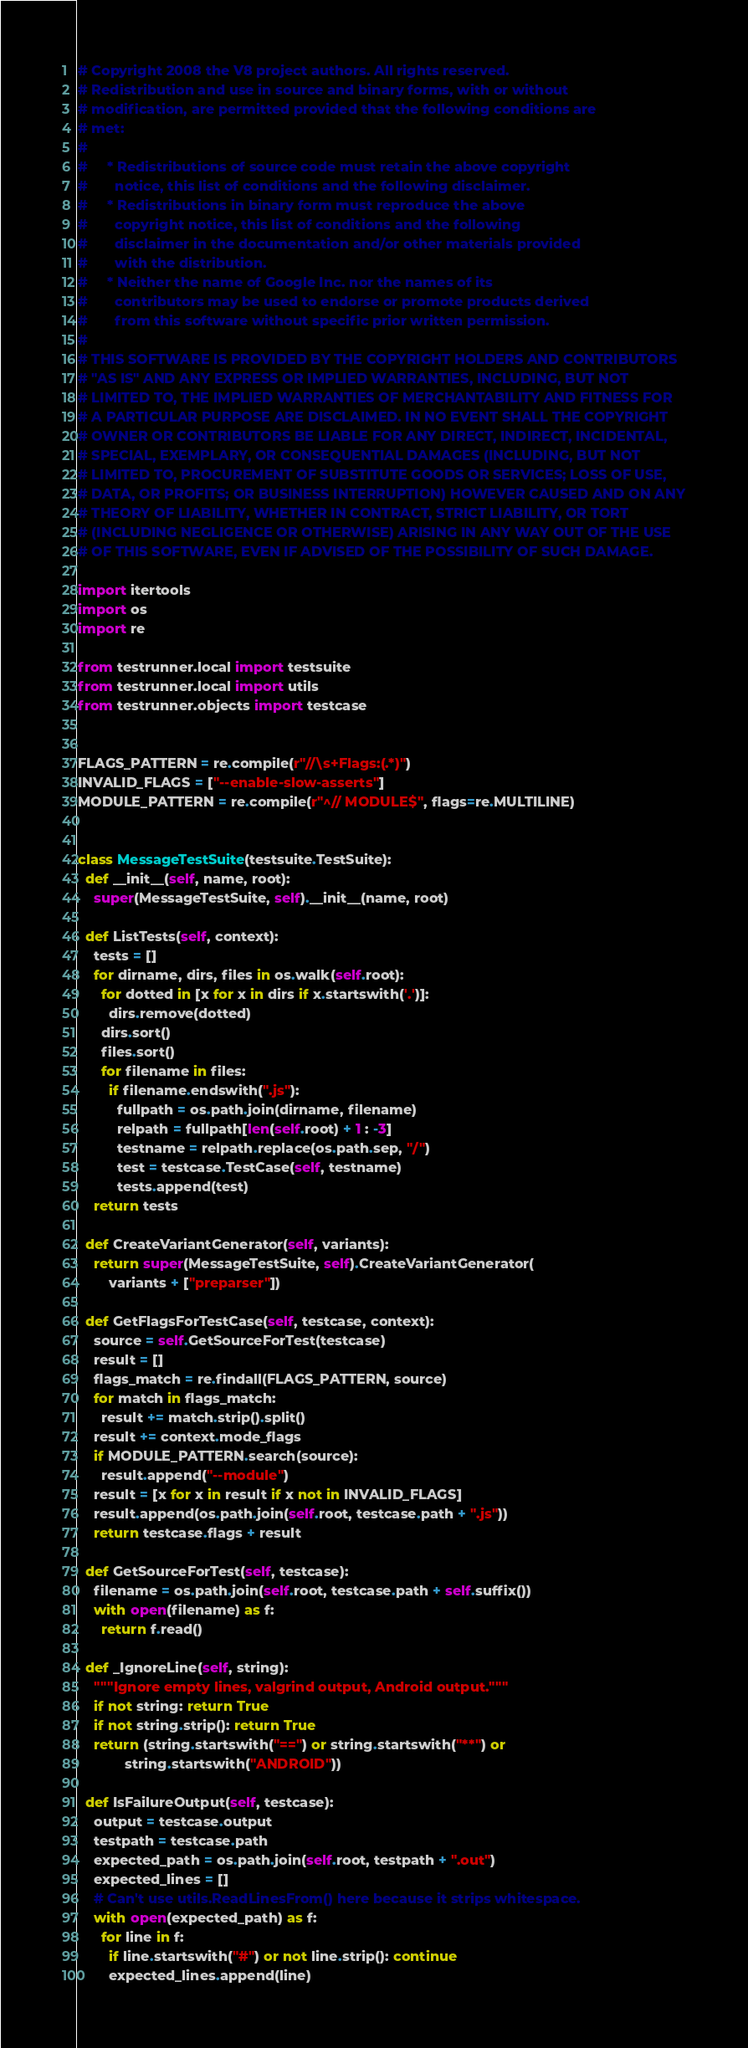Convert code to text. <code><loc_0><loc_0><loc_500><loc_500><_Python_># Copyright 2008 the V8 project authors. All rights reserved.
# Redistribution and use in source and binary forms, with or without
# modification, are permitted provided that the following conditions are
# met:
#
#     * Redistributions of source code must retain the above copyright
#       notice, this list of conditions and the following disclaimer.
#     * Redistributions in binary form must reproduce the above
#       copyright notice, this list of conditions and the following
#       disclaimer in the documentation and/or other materials provided
#       with the distribution.
#     * Neither the name of Google Inc. nor the names of its
#       contributors may be used to endorse or promote products derived
#       from this software without specific prior written permission.
#
# THIS SOFTWARE IS PROVIDED BY THE COPYRIGHT HOLDERS AND CONTRIBUTORS
# "AS IS" AND ANY EXPRESS OR IMPLIED WARRANTIES, INCLUDING, BUT NOT
# LIMITED TO, THE IMPLIED WARRANTIES OF MERCHANTABILITY AND FITNESS FOR
# A PARTICULAR PURPOSE ARE DISCLAIMED. IN NO EVENT SHALL THE COPYRIGHT
# OWNER OR CONTRIBUTORS BE LIABLE FOR ANY DIRECT, INDIRECT, INCIDENTAL,
# SPECIAL, EXEMPLARY, OR CONSEQUENTIAL DAMAGES (INCLUDING, BUT NOT
# LIMITED TO, PROCUREMENT OF SUBSTITUTE GOODS OR SERVICES; LOSS OF USE,
# DATA, OR PROFITS; OR BUSINESS INTERRUPTION) HOWEVER CAUSED AND ON ANY
# THEORY OF LIABILITY, WHETHER IN CONTRACT, STRICT LIABILITY, OR TORT
# (INCLUDING NEGLIGENCE OR OTHERWISE) ARISING IN ANY WAY OUT OF THE USE
# OF THIS SOFTWARE, EVEN IF ADVISED OF THE POSSIBILITY OF SUCH DAMAGE.

import itertools
import os
import re

from testrunner.local import testsuite
from testrunner.local import utils
from testrunner.objects import testcase


FLAGS_PATTERN = re.compile(r"//\s+Flags:(.*)")
INVALID_FLAGS = ["--enable-slow-asserts"]
MODULE_PATTERN = re.compile(r"^// MODULE$", flags=re.MULTILINE)


class MessageTestSuite(testsuite.TestSuite):
  def __init__(self, name, root):
    super(MessageTestSuite, self).__init__(name, root)

  def ListTests(self, context):
    tests = []
    for dirname, dirs, files in os.walk(self.root):
      for dotted in [x for x in dirs if x.startswith('.')]:
        dirs.remove(dotted)
      dirs.sort()
      files.sort()
      for filename in files:
        if filename.endswith(".js"):
          fullpath = os.path.join(dirname, filename)
          relpath = fullpath[len(self.root) + 1 : -3]
          testname = relpath.replace(os.path.sep, "/")
          test = testcase.TestCase(self, testname)
          tests.append(test)
    return tests

  def CreateVariantGenerator(self, variants):
    return super(MessageTestSuite, self).CreateVariantGenerator(
        variants + ["preparser"])

  def GetFlagsForTestCase(self, testcase, context):
    source = self.GetSourceForTest(testcase)
    result = []
    flags_match = re.findall(FLAGS_PATTERN, source)
    for match in flags_match:
      result += match.strip().split()
    result += context.mode_flags
    if MODULE_PATTERN.search(source):
      result.append("--module")
    result = [x for x in result if x not in INVALID_FLAGS]
    result.append(os.path.join(self.root, testcase.path + ".js"))
    return testcase.flags + result

  def GetSourceForTest(self, testcase):
    filename = os.path.join(self.root, testcase.path + self.suffix())
    with open(filename) as f:
      return f.read()

  def _IgnoreLine(self, string):
    """Ignore empty lines, valgrind output, Android output."""
    if not string: return True
    if not string.strip(): return True
    return (string.startswith("==") or string.startswith("**") or
            string.startswith("ANDROID"))

  def IsFailureOutput(self, testcase):
    output = testcase.output
    testpath = testcase.path
    expected_path = os.path.join(self.root, testpath + ".out")
    expected_lines = []
    # Can't use utils.ReadLinesFrom() here because it strips whitespace.
    with open(expected_path) as f:
      for line in f:
        if line.startswith("#") or not line.strip(): continue
        expected_lines.append(line)</code> 